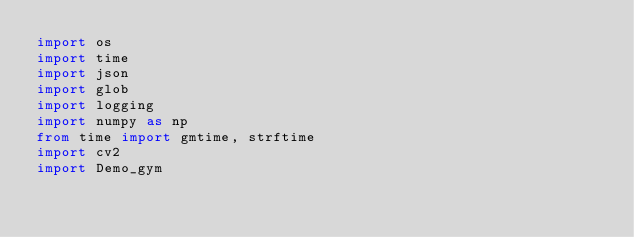Convert code to text. <code><loc_0><loc_0><loc_500><loc_500><_Python_>import os
import time
import json
import glob
import logging
import numpy as np
from time import gmtime, strftime
import cv2
import Demo_gym</code> 